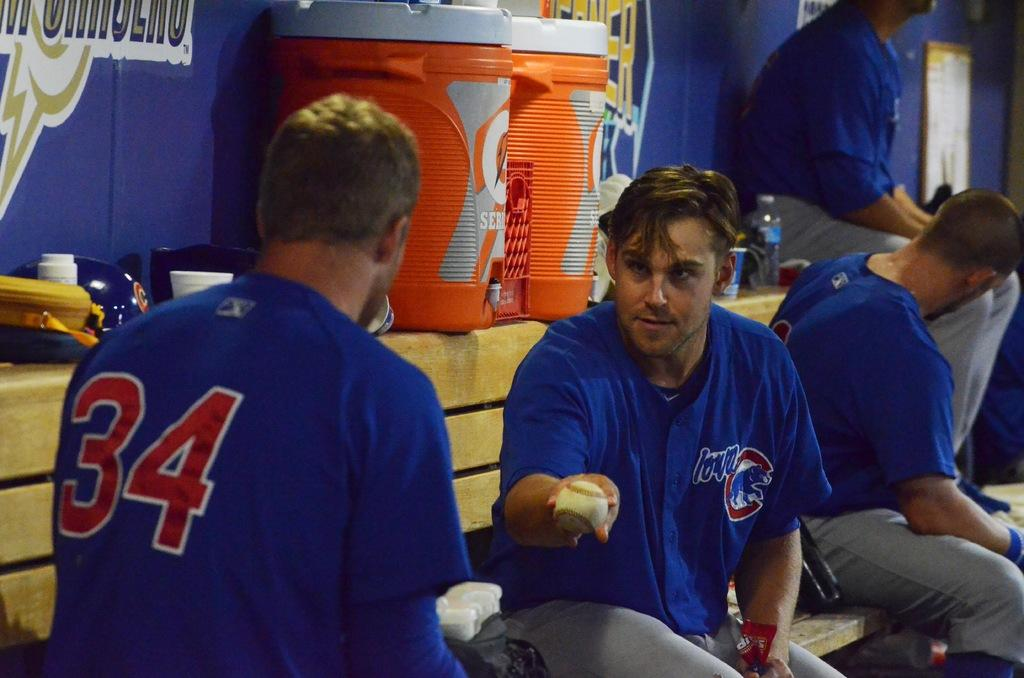<image>
Provide a brief description of the given image. Cubs #34 is chatting with another Cub holding a baseball 